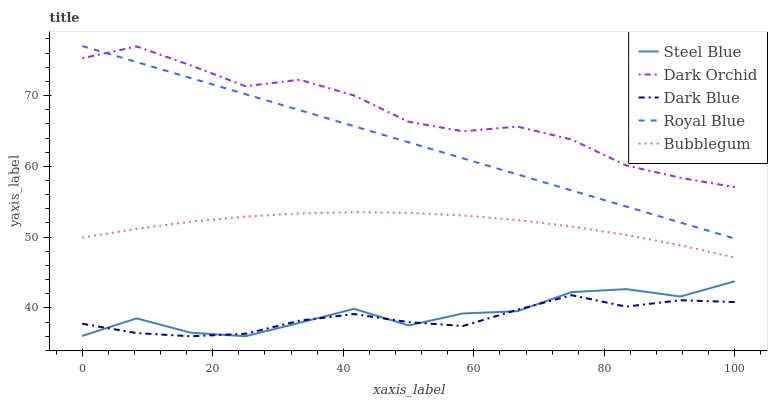Does Dark Blue have the minimum area under the curve?
Answer yes or no. Yes. Does Dark Orchid have the maximum area under the curve?
Answer yes or no. Yes. Does Bubblegum have the minimum area under the curve?
Answer yes or no. No. Does Bubblegum have the maximum area under the curve?
Answer yes or no. No. Is Royal Blue the smoothest?
Answer yes or no. Yes. Is Steel Blue the roughest?
Answer yes or no. Yes. Is Bubblegum the smoothest?
Answer yes or no. No. Is Bubblegum the roughest?
Answer yes or no. No. Does Dark Blue have the lowest value?
Answer yes or no. Yes. Does Bubblegum have the lowest value?
Answer yes or no. No. Does Royal Blue have the highest value?
Answer yes or no. Yes. Does Bubblegum have the highest value?
Answer yes or no. No. Is Dark Blue less than Royal Blue?
Answer yes or no. Yes. Is Bubblegum greater than Steel Blue?
Answer yes or no. Yes. Does Dark Orchid intersect Royal Blue?
Answer yes or no. Yes. Is Dark Orchid less than Royal Blue?
Answer yes or no. No. Is Dark Orchid greater than Royal Blue?
Answer yes or no. No. Does Dark Blue intersect Royal Blue?
Answer yes or no. No. 